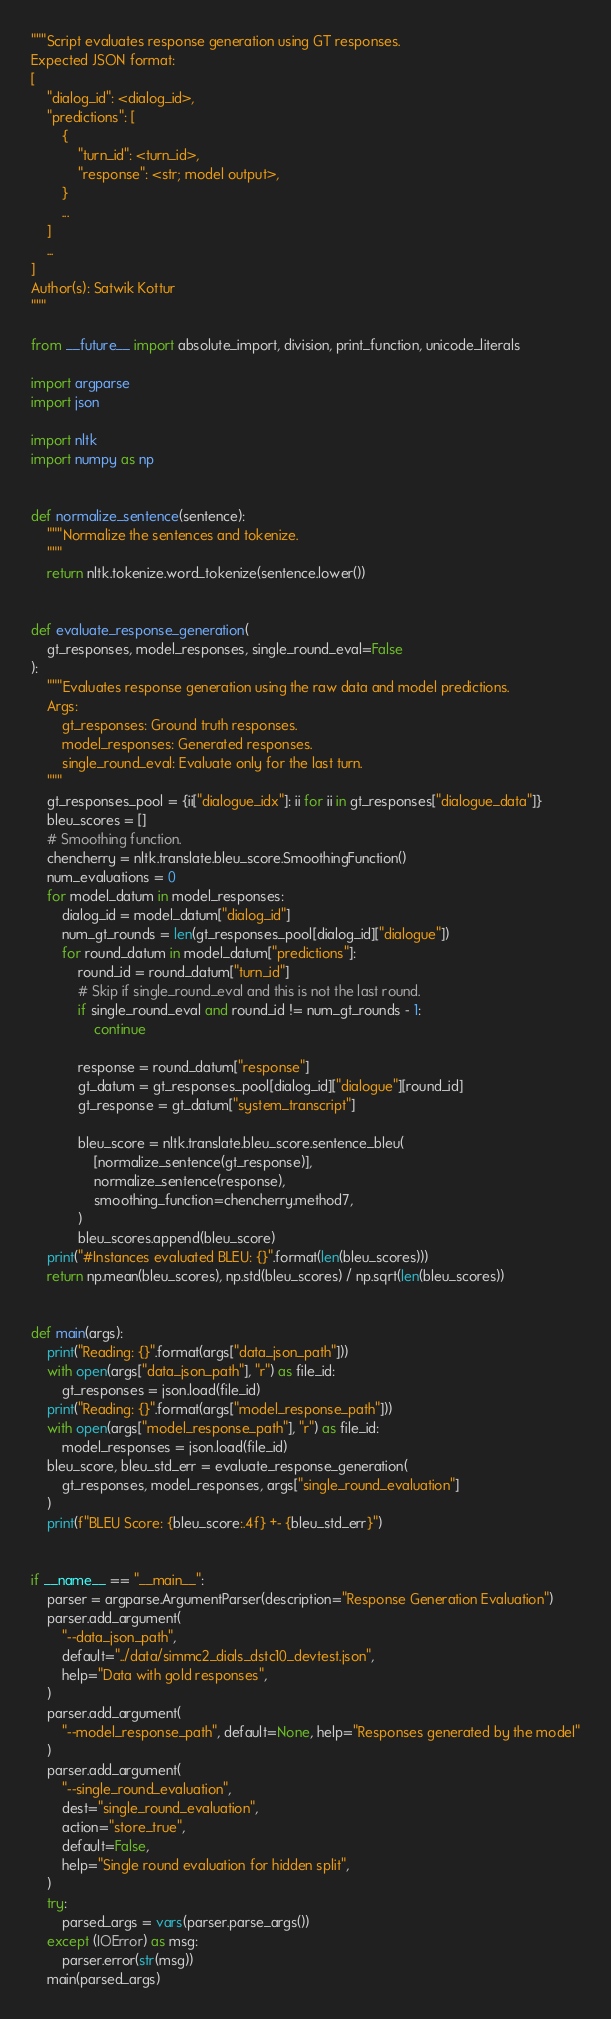Convert code to text. <code><loc_0><loc_0><loc_500><loc_500><_Python_>"""Script evaluates response generation using GT responses.
Expected JSON format:
[
    "dialog_id": <dialog_id>,
    "predictions": [
        {
            "turn_id": <turn_id>,
            "response": <str; model output>,
        }
        ...
    ]
    ...
]
Author(s): Satwik Kottur
"""

from __future__ import absolute_import, division, print_function, unicode_literals

import argparse
import json

import nltk
import numpy as np


def normalize_sentence(sentence):
    """Normalize the sentences and tokenize.
    """
    return nltk.tokenize.word_tokenize(sentence.lower())


def evaluate_response_generation(
    gt_responses, model_responses, single_round_eval=False
):
    """Evaluates response generation using the raw data and model predictions.
    Args:
        gt_responses: Ground truth responses.
        model_responses: Generated responses.
        single_round_eval: Evaluate only for the last turn.
    """
    gt_responses_pool = {ii["dialogue_idx"]: ii for ii in gt_responses["dialogue_data"]}
    bleu_scores = []
    # Smoothing function.
    chencherry = nltk.translate.bleu_score.SmoothingFunction()
    num_evaluations = 0
    for model_datum in model_responses:
        dialog_id = model_datum["dialog_id"]
        num_gt_rounds = len(gt_responses_pool[dialog_id]["dialogue"])
        for round_datum in model_datum["predictions"]:
            round_id = round_datum["turn_id"]
            # Skip if single_round_eval and this is not the last round.
            if single_round_eval and round_id != num_gt_rounds - 1:
                continue

            response = round_datum["response"]
            gt_datum = gt_responses_pool[dialog_id]["dialogue"][round_id]
            gt_response = gt_datum["system_transcript"]

            bleu_score = nltk.translate.bleu_score.sentence_bleu(
                [normalize_sentence(gt_response)],
                normalize_sentence(response),
                smoothing_function=chencherry.method7,
            )
            bleu_scores.append(bleu_score)
    print("#Instances evaluated BLEU: {}".format(len(bleu_scores)))
    return np.mean(bleu_scores), np.std(bleu_scores) / np.sqrt(len(bleu_scores))


def main(args):
    print("Reading: {}".format(args["data_json_path"]))
    with open(args["data_json_path"], "r") as file_id:
        gt_responses = json.load(file_id)
    print("Reading: {}".format(args["model_response_path"]))
    with open(args["model_response_path"], "r") as file_id:
        model_responses = json.load(file_id)
    bleu_score, bleu_std_err = evaluate_response_generation(
        gt_responses, model_responses, args["single_round_evaluation"]
    )
    print(f"BLEU Score: {bleu_score:.4f} +- {bleu_std_err}")


if __name__ == "__main__":
    parser = argparse.ArgumentParser(description="Response Generation Evaluation")
    parser.add_argument(
        "--data_json_path",
        default="../data/simmc2_dials_dstc10_devtest.json",
        help="Data with gold responses",
    )
    parser.add_argument(
        "--model_response_path", default=None, help="Responses generated by the model"
    )
    parser.add_argument(
        "--single_round_evaluation",
        dest="single_round_evaluation",
        action="store_true",
        default=False,
        help="Single round evaluation for hidden split",
    )
    try:
        parsed_args = vars(parser.parse_args())
    except (IOError) as msg:
        parser.error(str(msg))
    main(parsed_args)</code> 